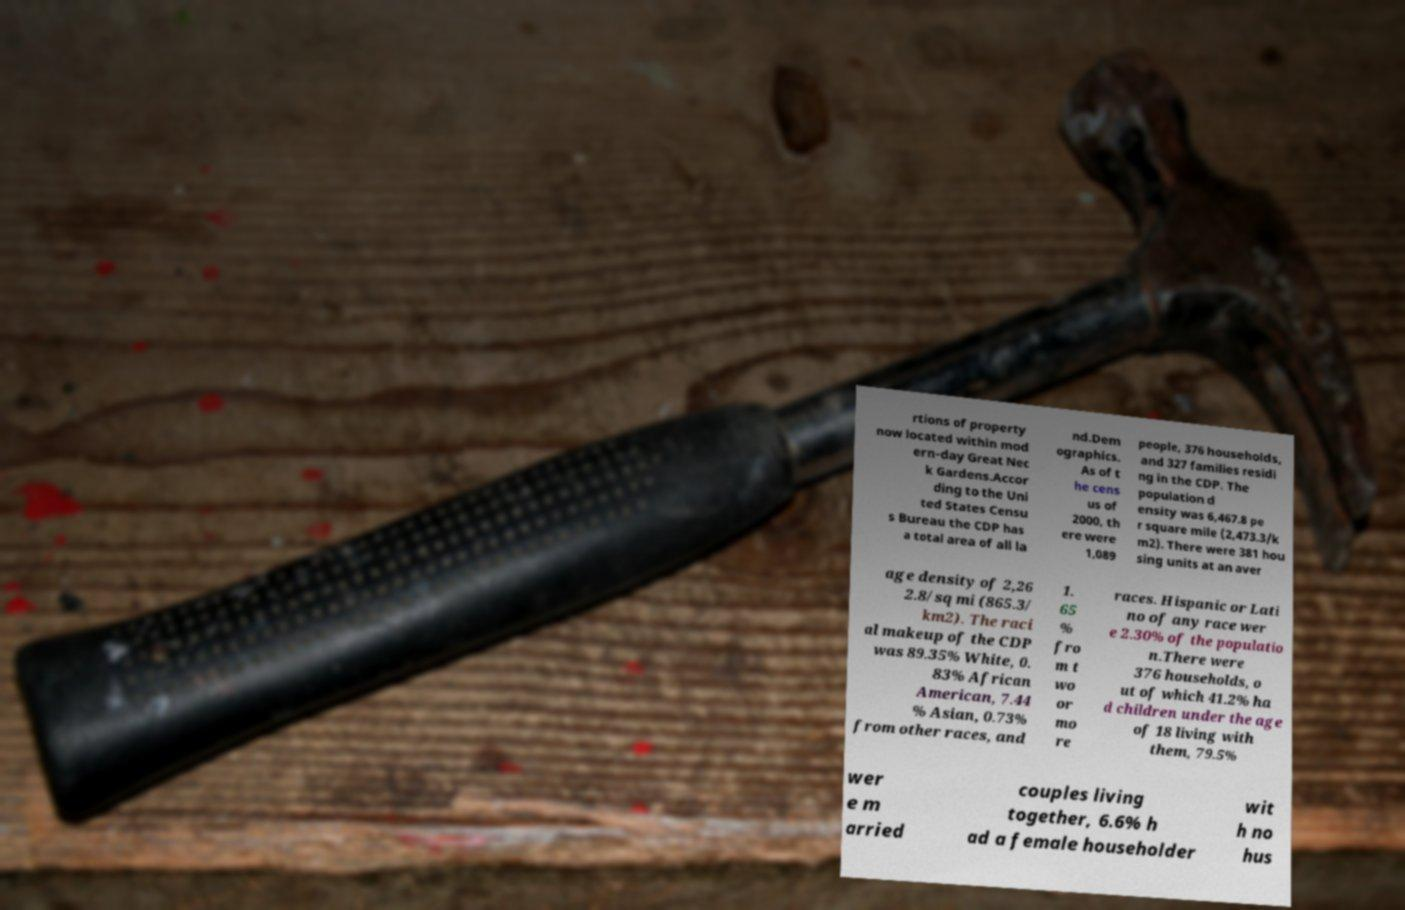I need the written content from this picture converted into text. Can you do that? rtions of property now located within mod ern-day Great Nec k Gardens.Accor ding to the Uni ted States Censu s Bureau the CDP has a total area of all la nd.Dem ographics. As of t he cens us of 2000, th ere were 1,089 people, 376 households, and 327 families residi ng in the CDP. The population d ensity was 6,467.8 pe r square mile (2,473.3/k m2). There were 381 hou sing units at an aver age density of 2,26 2.8/sq mi (865.3/ km2). The raci al makeup of the CDP was 89.35% White, 0. 83% African American, 7.44 % Asian, 0.73% from other races, and 1. 65 % fro m t wo or mo re races. Hispanic or Lati no of any race wer e 2.30% of the populatio n.There were 376 households, o ut of which 41.2% ha d children under the age of 18 living with them, 79.5% wer e m arried couples living together, 6.6% h ad a female householder wit h no hus 